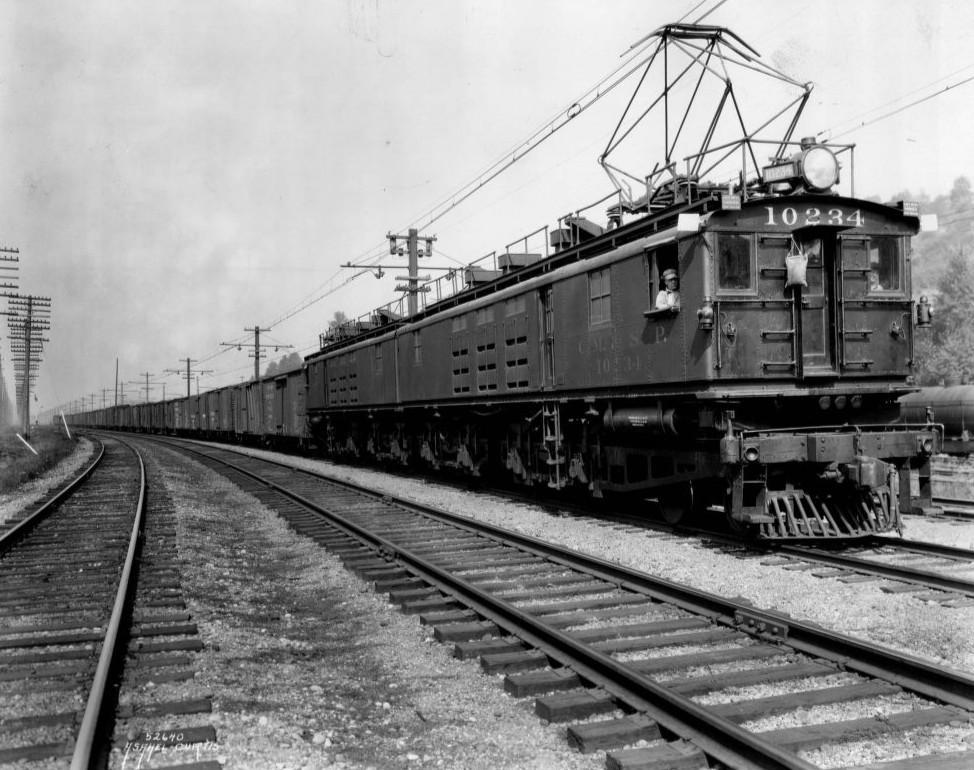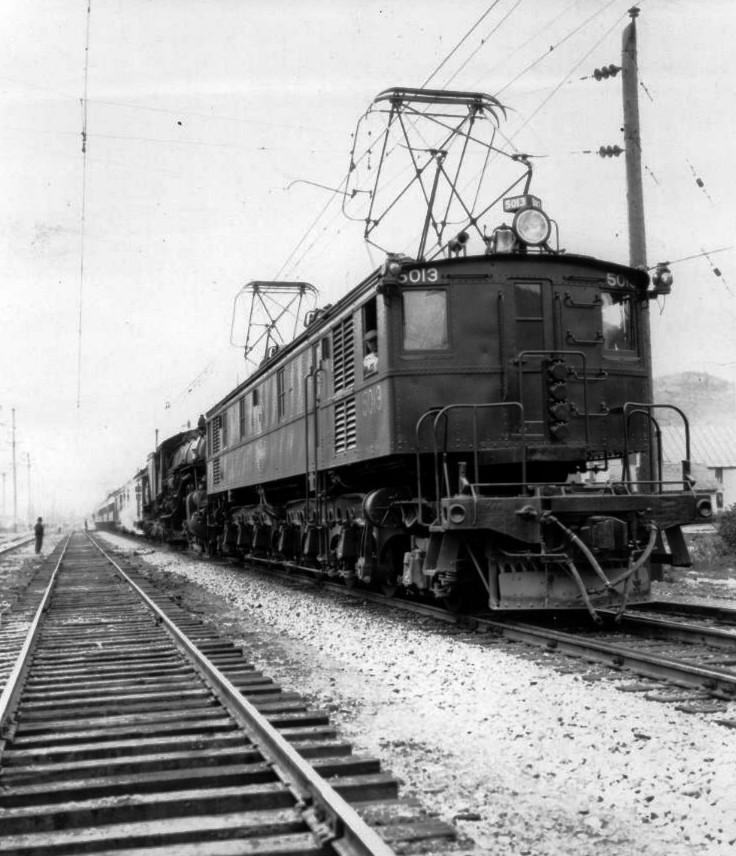The first image is the image on the left, the second image is the image on the right. For the images shown, is this caption "One image has a train in front of mountains and is in color." true? Answer yes or no. No. The first image is the image on the left, the second image is the image on the right. Given the left and right images, does the statement "There is an electric train travelling on the rails." hold true? Answer yes or no. Yes. 